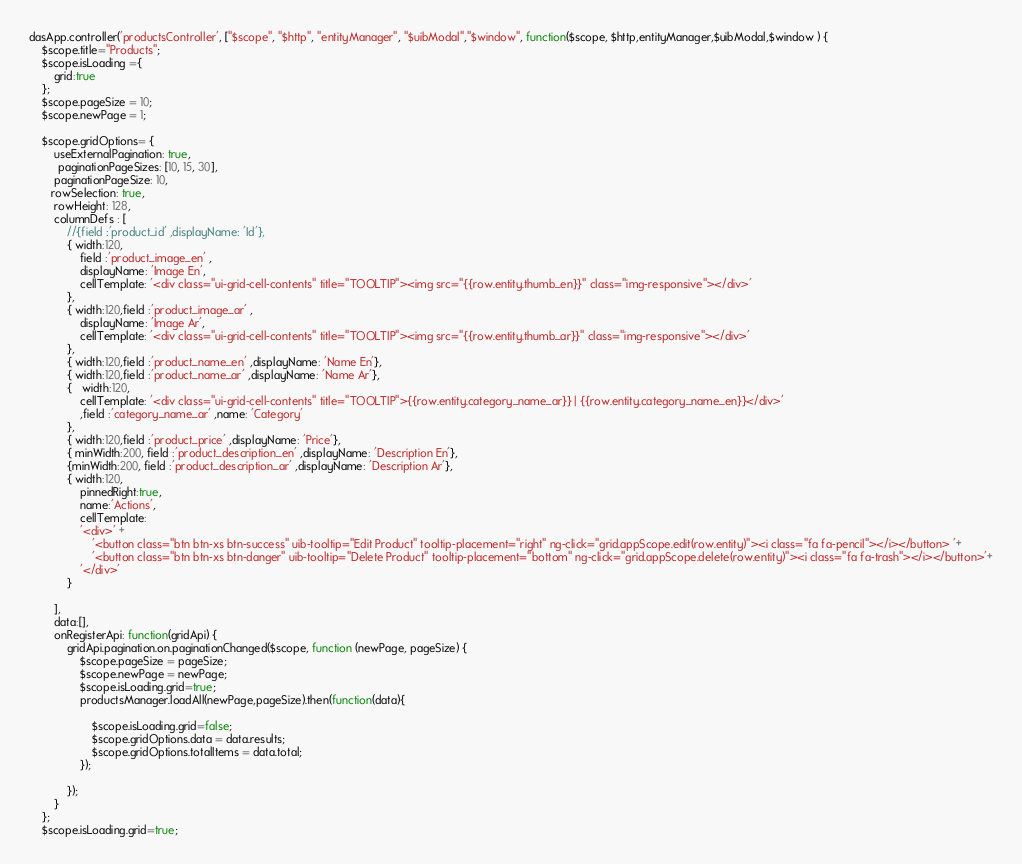<code> <loc_0><loc_0><loc_500><loc_500><_JavaScript_>dasApp.controller('productsController', ["$scope", "$http", "entityManager", "$uibModal","$window", function($scope, $http,entityManager,$uibModal,$window ) {
    $scope.title="Products";
	$scope.isLoading ={
        grid:true
    };
	$scope.pageSize = 10;
	$scope.newPage = 1;
	
    $scope.gridOptions= {
        useExternalPagination: true,
         paginationPageSizes: [10, 15, 30],
        paginationPageSize: 10,
       rowSelection: true,
        rowHeight: 128,
        columnDefs : [
            //{field :'product_id' ,displayName: 'Id'},
            { width:120,
                field :'product_image_en' ,
                displayName: 'Image En',
                cellTemplate: '<div class="ui-grid-cell-contents" title="TOOLTIP"><img src="{{row.entity.thumb_en}}" class="img-responsive"></div>'
            },
            { width:120,field :'product_image_ar' ,
                displayName: 'Image Ar',
                cellTemplate: '<div class="ui-grid-cell-contents" title="TOOLTIP"><img src="{{row.entity.thumb_ar}}" class="img-responsive"></div>'
            },
            { width:120,field :'product_name_en' ,displayName: 'Name En'},
            { width:120,field :'product_name_ar' ,displayName: 'Name Ar'},
            {   width:120,
                cellTemplate: '<div class="ui-grid-cell-contents" title="TOOLTIP">{{row.entity.category_name_ar}} | {{row.entity.category_name_en}}</div>'
                ,field :'category_name_ar' ,name: 'Category'
            },
            { width:120,field :'product_price' ,displayName: 'Price'},
            { minWidth:200, field :'product_description_en' ,displayName: 'Description En'},
            {minWidth:200, field :'product_description_ar' ,displayName: 'Description Ar'},
            { width:120,
                pinnedRight:true,
                name:'Actions',
                cellTemplate:
                '<div>' +
                    '<button class="btn btn-xs btn-success" uib-tooltip="Edit Product" tooltip-placement="right" ng-click="grid.appScope.edit(row.entity)"><i class="fa fa-pencil"></i></button> '+
                    '<button class="btn btn-xs btn-danger" uib-tooltip="Delete Product" tooltip-placement="bottom" ng-click="grid.appScope.delete(row.entity)"><i class="fa fa-trash"></i></button>'+
                '</div>'
            }

        ],
        data:[],
        onRegisterApi: function(gridApi) {
            gridApi.pagination.on.paginationChanged($scope, function (newPage, pageSize) {
				$scope.pageSize = pageSize;
				$scope.newPage = newPage;
                $scope.isLoading.grid=true;
				productsManager.loadAll(newPage,pageSize).then(function(data){
					
					$scope.isLoading.grid=false;
					$scope.gridOptions.data = data.results;
                    $scope.gridOptions.totalItems = data.total;
                });

            });
        }
    };
    $scope.isLoading.grid=true;</code> 